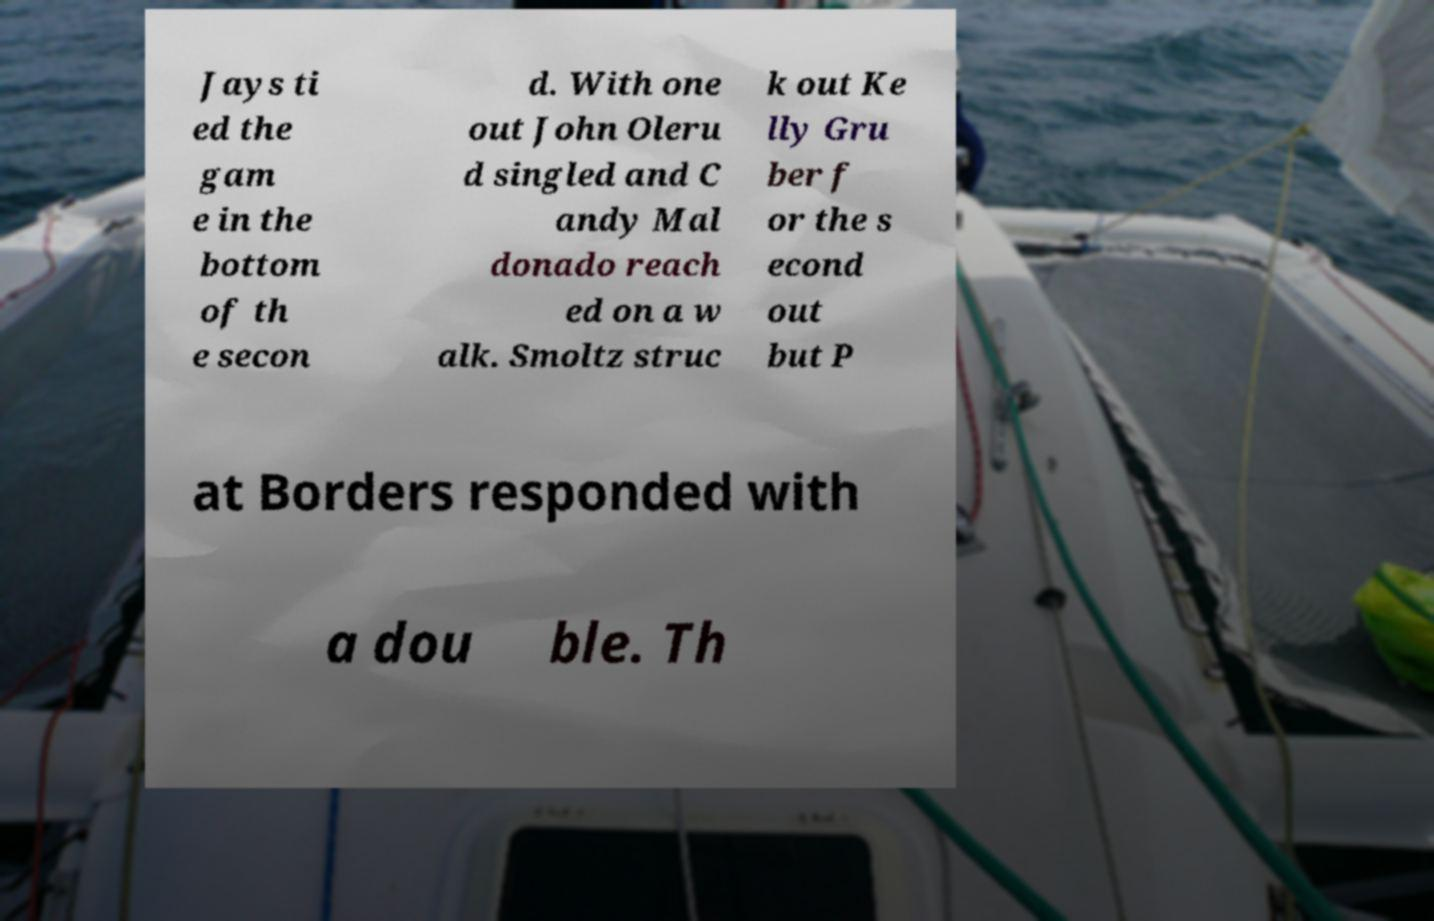What messages or text are displayed in this image? I need them in a readable, typed format. Jays ti ed the gam e in the bottom of th e secon d. With one out John Oleru d singled and C andy Mal donado reach ed on a w alk. Smoltz struc k out Ke lly Gru ber f or the s econd out but P at Borders responded with a dou ble. Th 